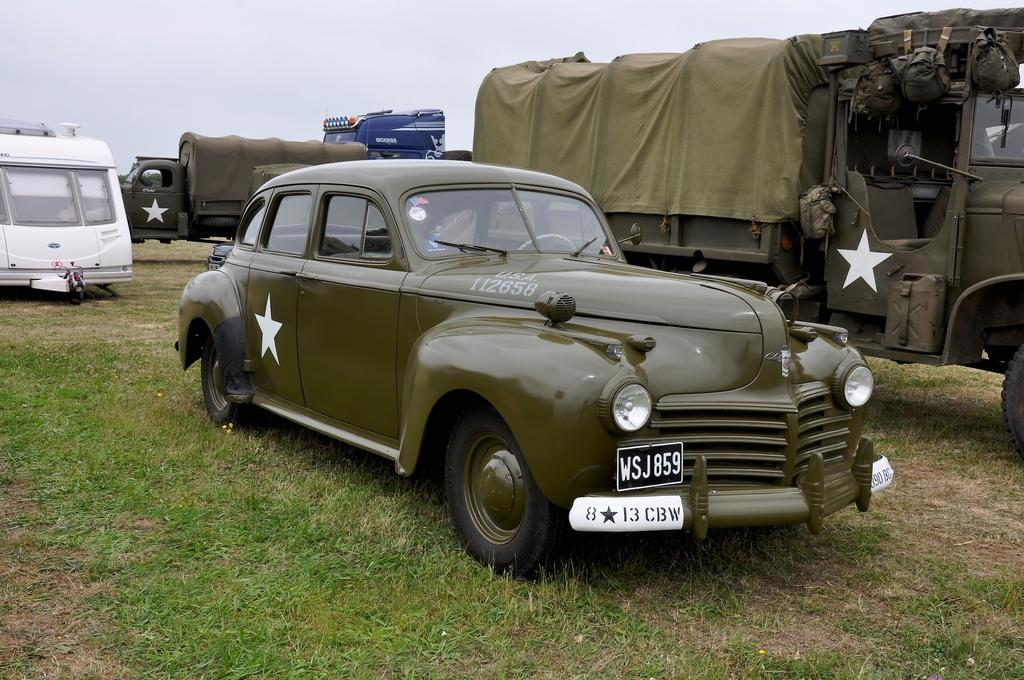What types of vehicles can be seen in the image? There are vehicles of different colors in the image. What features do the vehicles have? The vehicles have headlights and number plates. What can be seen in the background of the image? There is grass and the sky visible in the image. What type of jeans is the amusement park wearing in the image? There is no amusement park or jeans present in the image. What sense is being stimulated by the vehicles in the image? The image does not provide information about senses being stimulated by the vehicles. 